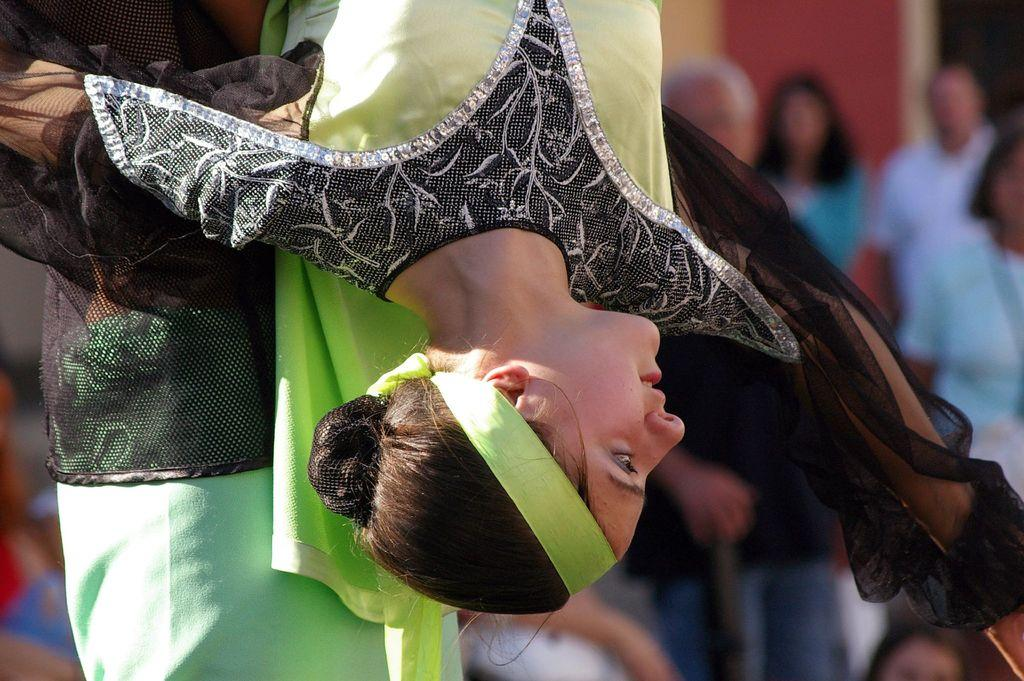What is the main subject of the image? The main subject of the image is a woman. What is the woman doing in the image? The woman is in an upside-down position. Is there anyone else in the image? Yes, there is a person standing next to the woman in the image. What are the two people wearing? Both the woman and the person are wearing clothes. Can you describe the background of the image? The background of the image is blurred. What type of pear can be seen rolling on the floor in the image? There is no pear present in the image, and therefore no such activity can be observed. 